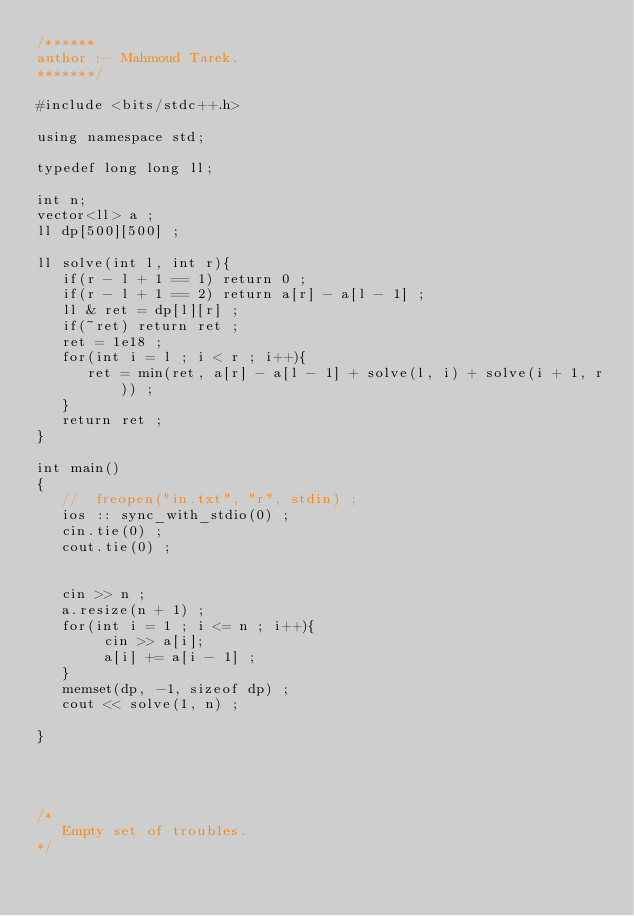Convert code to text. <code><loc_0><loc_0><loc_500><loc_500><_C++_>/******
author :- Mahmoud Tarek.
*******/

#include <bits/stdc++.h>

using namespace std;

typedef long long ll;

int n;
vector<ll> a ;
ll dp[500][500] ;

ll solve(int l, int r){
   if(r - l + 1 == 1) return 0 ;
   if(r - l + 1 == 2) return a[r] - a[l - 1] ;
   ll & ret = dp[l][r] ;
   if(~ret) return ret ;
   ret = 1e18 ;
   for(int i = l ; i < r ; i++){
      ret = min(ret, a[r] - a[l - 1] + solve(l, i) + solve(i + 1, r)) ;
   }
   return ret ;
}

int main()
{
   //  freopen("in.txt", "r", stdin) ;
   ios :: sync_with_stdio(0) ;
   cin.tie(0) ;
   cout.tie(0) ;


   cin >> n ;
   a.resize(n + 1) ;
   for(int i = 1 ; i <= n ; i++){
        cin >> a[i];
        a[i] += a[i - 1] ;
   }
   memset(dp, -1, sizeof dp) ;
   cout << solve(1, n) ;

}




/*
   Empty set of troubles.
*/
</code> 